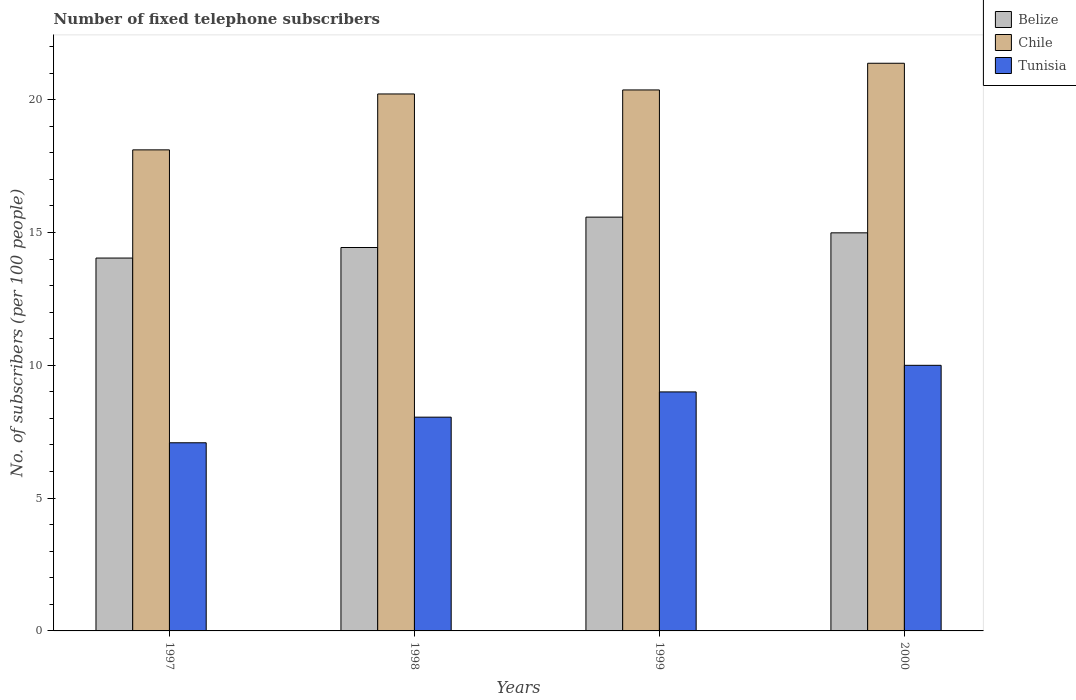How many groups of bars are there?
Your answer should be compact. 4. Are the number of bars per tick equal to the number of legend labels?
Give a very brief answer. Yes. Are the number of bars on each tick of the X-axis equal?
Your response must be concise. Yes. How many bars are there on the 4th tick from the left?
Offer a terse response. 3. How many bars are there on the 1st tick from the right?
Make the answer very short. 3. In how many cases, is the number of bars for a given year not equal to the number of legend labels?
Ensure brevity in your answer.  0. What is the number of fixed telephone subscribers in Belize in 1999?
Give a very brief answer. 15.58. Across all years, what is the maximum number of fixed telephone subscribers in Belize?
Offer a terse response. 15.58. Across all years, what is the minimum number of fixed telephone subscribers in Chile?
Offer a terse response. 18.11. In which year was the number of fixed telephone subscribers in Tunisia maximum?
Keep it short and to the point. 2000. In which year was the number of fixed telephone subscribers in Chile minimum?
Ensure brevity in your answer.  1997. What is the total number of fixed telephone subscribers in Chile in the graph?
Ensure brevity in your answer.  80.06. What is the difference between the number of fixed telephone subscribers in Tunisia in 1998 and that in 1999?
Make the answer very short. -0.95. What is the difference between the number of fixed telephone subscribers in Belize in 2000 and the number of fixed telephone subscribers in Chile in 1997?
Keep it short and to the point. -3.12. What is the average number of fixed telephone subscribers in Belize per year?
Provide a short and direct response. 14.76. In the year 2000, what is the difference between the number of fixed telephone subscribers in Tunisia and number of fixed telephone subscribers in Belize?
Your answer should be compact. -4.99. In how many years, is the number of fixed telephone subscribers in Belize greater than 3?
Your response must be concise. 4. What is the ratio of the number of fixed telephone subscribers in Belize in 1998 to that in 1999?
Make the answer very short. 0.93. Is the number of fixed telephone subscribers in Chile in 1998 less than that in 2000?
Your response must be concise. Yes. Is the difference between the number of fixed telephone subscribers in Tunisia in 1997 and 2000 greater than the difference between the number of fixed telephone subscribers in Belize in 1997 and 2000?
Provide a short and direct response. No. What is the difference between the highest and the second highest number of fixed telephone subscribers in Chile?
Provide a succinct answer. 1. What is the difference between the highest and the lowest number of fixed telephone subscribers in Belize?
Give a very brief answer. 1.54. In how many years, is the number of fixed telephone subscribers in Tunisia greater than the average number of fixed telephone subscribers in Tunisia taken over all years?
Make the answer very short. 2. What does the 3rd bar from the left in 1998 represents?
Offer a very short reply. Tunisia. What does the 1st bar from the right in 2000 represents?
Offer a very short reply. Tunisia. Is it the case that in every year, the sum of the number of fixed telephone subscribers in Tunisia and number of fixed telephone subscribers in Belize is greater than the number of fixed telephone subscribers in Chile?
Make the answer very short. Yes. How many bars are there?
Give a very brief answer. 12. Are the values on the major ticks of Y-axis written in scientific E-notation?
Offer a terse response. No. Does the graph contain any zero values?
Offer a terse response. No. Does the graph contain grids?
Provide a short and direct response. No. How many legend labels are there?
Ensure brevity in your answer.  3. How are the legend labels stacked?
Offer a terse response. Vertical. What is the title of the graph?
Provide a succinct answer. Number of fixed telephone subscribers. Does "North America" appear as one of the legend labels in the graph?
Make the answer very short. No. What is the label or title of the X-axis?
Offer a very short reply. Years. What is the label or title of the Y-axis?
Provide a short and direct response. No. of subscribers (per 100 people). What is the No. of subscribers (per 100 people) in Belize in 1997?
Your answer should be very brief. 14.04. What is the No. of subscribers (per 100 people) of Chile in 1997?
Offer a very short reply. 18.11. What is the No. of subscribers (per 100 people) in Tunisia in 1997?
Give a very brief answer. 7.08. What is the No. of subscribers (per 100 people) in Belize in 1998?
Ensure brevity in your answer.  14.43. What is the No. of subscribers (per 100 people) in Chile in 1998?
Provide a succinct answer. 20.21. What is the No. of subscribers (per 100 people) of Tunisia in 1998?
Give a very brief answer. 8.05. What is the No. of subscribers (per 100 people) in Belize in 1999?
Your answer should be compact. 15.58. What is the No. of subscribers (per 100 people) in Chile in 1999?
Provide a succinct answer. 20.36. What is the No. of subscribers (per 100 people) of Tunisia in 1999?
Your answer should be compact. 9. What is the No. of subscribers (per 100 people) in Belize in 2000?
Your answer should be compact. 14.99. What is the No. of subscribers (per 100 people) in Chile in 2000?
Make the answer very short. 21.37. What is the No. of subscribers (per 100 people) of Tunisia in 2000?
Offer a terse response. 10. Across all years, what is the maximum No. of subscribers (per 100 people) in Belize?
Offer a terse response. 15.58. Across all years, what is the maximum No. of subscribers (per 100 people) of Chile?
Offer a terse response. 21.37. Across all years, what is the maximum No. of subscribers (per 100 people) in Tunisia?
Give a very brief answer. 10. Across all years, what is the minimum No. of subscribers (per 100 people) of Belize?
Offer a terse response. 14.04. Across all years, what is the minimum No. of subscribers (per 100 people) of Chile?
Your answer should be compact. 18.11. Across all years, what is the minimum No. of subscribers (per 100 people) in Tunisia?
Your answer should be compact. 7.08. What is the total No. of subscribers (per 100 people) of Belize in the graph?
Provide a short and direct response. 59.03. What is the total No. of subscribers (per 100 people) of Chile in the graph?
Offer a terse response. 80.06. What is the total No. of subscribers (per 100 people) of Tunisia in the graph?
Your answer should be compact. 34.13. What is the difference between the No. of subscribers (per 100 people) of Belize in 1997 and that in 1998?
Ensure brevity in your answer.  -0.4. What is the difference between the No. of subscribers (per 100 people) in Chile in 1997 and that in 1998?
Offer a very short reply. -2.1. What is the difference between the No. of subscribers (per 100 people) in Tunisia in 1997 and that in 1998?
Offer a terse response. -0.96. What is the difference between the No. of subscribers (per 100 people) of Belize in 1997 and that in 1999?
Make the answer very short. -1.54. What is the difference between the No. of subscribers (per 100 people) of Chile in 1997 and that in 1999?
Make the answer very short. -2.26. What is the difference between the No. of subscribers (per 100 people) of Tunisia in 1997 and that in 1999?
Ensure brevity in your answer.  -1.91. What is the difference between the No. of subscribers (per 100 people) in Belize in 1997 and that in 2000?
Provide a succinct answer. -0.95. What is the difference between the No. of subscribers (per 100 people) of Chile in 1997 and that in 2000?
Keep it short and to the point. -3.26. What is the difference between the No. of subscribers (per 100 people) in Tunisia in 1997 and that in 2000?
Make the answer very short. -2.92. What is the difference between the No. of subscribers (per 100 people) in Belize in 1998 and that in 1999?
Offer a very short reply. -1.14. What is the difference between the No. of subscribers (per 100 people) of Chile in 1998 and that in 1999?
Provide a succinct answer. -0.15. What is the difference between the No. of subscribers (per 100 people) in Tunisia in 1998 and that in 1999?
Ensure brevity in your answer.  -0.95. What is the difference between the No. of subscribers (per 100 people) in Belize in 1998 and that in 2000?
Your answer should be compact. -0.55. What is the difference between the No. of subscribers (per 100 people) in Chile in 1998 and that in 2000?
Offer a very short reply. -1.16. What is the difference between the No. of subscribers (per 100 people) in Tunisia in 1998 and that in 2000?
Ensure brevity in your answer.  -1.95. What is the difference between the No. of subscribers (per 100 people) of Belize in 1999 and that in 2000?
Your response must be concise. 0.59. What is the difference between the No. of subscribers (per 100 people) of Chile in 1999 and that in 2000?
Make the answer very short. -1. What is the difference between the No. of subscribers (per 100 people) of Tunisia in 1999 and that in 2000?
Make the answer very short. -1. What is the difference between the No. of subscribers (per 100 people) of Belize in 1997 and the No. of subscribers (per 100 people) of Chile in 1998?
Your response must be concise. -6.18. What is the difference between the No. of subscribers (per 100 people) of Belize in 1997 and the No. of subscribers (per 100 people) of Tunisia in 1998?
Your answer should be very brief. 5.99. What is the difference between the No. of subscribers (per 100 people) in Chile in 1997 and the No. of subscribers (per 100 people) in Tunisia in 1998?
Provide a succinct answer. 10.06. What is the difference between the No. of subscribers (per 100 people) of Belize in 1997 and the No. of subscribers (per 100 people) of Chile in 1999?
Your response must be concise. -6.33. What is the difference between the No. of subscribers (per 100 people) in Belize in 1997 and the No. of subscribers (per 100 people) in Tunisia in 1999?
Your answer should be compact. 5.04. What is the difference between the No. of subscribers (per 100 people) of Chile in 1997 and the No. of subscribers (per 100 people) of Tunisia in 1999?
Your response must be concise. 9.11. What is the difference between the No. of subscribers (per 100 people) of Belize in 1997 and the No. of subscribers (per 100 people) of Chile in 2000?
Give a very brief answer. -7.33. What is the difference between the No. of subscribers (per 100 people) in Belize in 1997 and the No. of subscribers (per 100 people) in Tunisia in 2000?
Keep it short and to the point. 4.04. What is the difference between the No. of subscribers (per 100 people) of Chile in 1997 and the No. of subscribers (per 100 people) of Tunisia in 2000?
Offer a terse response. 8.11. What is the difference between the No. of subscribers (per 100 people) of Belize in 1998 and the No. of subscribers (per 100 people) of Chile in 1999?
Provide a short and direct response. -5.93. What is the difference between the No. of subscribers (per 100 people) of Belize in 1998 and the No. of subscribers (per 100 people) of Tunisia in 1999?
Ensure brevity in your answer.  5.44. What is the difference between the No. of subscribers (per 100 people) in Chile in 1998 and the No. of subscribers (per 100 people) in Tunisia in 1999?
Offer a very short reply. 11.22. What is the difference between the No. of subscribers (per 100 people) of Belize in 1998 and the No. of subscribers (per 100 people) of Chile in 2000?
Give a very brief answer. -6.94. What is the difference between the No. of subscribers (per 100 people) of Belize in 1998 and the No. of subscribers (per 100 people) of Tunisia in 2000?
Ensure brevity in your answer.  4.43. What is the difference between the No. of subscribers (per 100 people) in Chile in 1998 and the No. of subscribers (per 100 people) in Tunisia in 2000?
Offer a terse response. 10.22. What is the difference between the No. of subscribers (per 100 people) in Belize in 1999 and the No. of subscribers (per 100 people) in Chile in 2000?
Provide a short and direct response. -5.79. What is the difference between the No. of subscribers (per 100 people) in Belize in 1999 and the No. of subscribers (per 100 people) in Tunisia in 2000?
Keep it short and to the point. 5.58. What is the difference between the No. of subscribers (per 100 people) of Chile in 1999 and the No. of subscribers (per 100 people) of Tunisia in 2000?
Make the answer very short. 10.37. What is the average No. of subscribers (per 100 people) of Belize per year?
Offer a terse response. 14.76. What is the average No. of subscribers (per 100 people) in Chile per year?
Provide a succinct answer. 20.01. What is the average No. of subscribers (per 100 people) of Tunisia per year?
Offer a very short reply. 8.53. In the year 1997, what is the difference between the No. of subscribers (per 100 people) in Belize and No. of subscribers (per 100 people) in Chile?
Provide a short and direct response. -4.07. In the year 1997, what is the difference between the No. of subscribers (per 100 people) in Belize and No. of subscribers (per 100 people) in Tunisia?
Offer a very short reply. 6.95. In the year 1997, what is the difference between the No. of subscribers (per 100 people) of Chile and No. of subscribers (per 100 people) of Tunisia?
Offer a terse response. 11.03. In the year 1998, what is the difference between the No. of subscribers (per 100 people) of Belize and No. of subscribers (per 100 people) of Chile?
Your answer should be very brief. -5.78. In the year 1998, what is the difference between the No. of subscribers (per 100 people) of Belize and No. of subscribers (per 100 people) of Tunisia?
Your answer should be compact. 6.39. In the year 1998, what is the difference between the No. of subscribers (per 100 people) in Chile and No. of subscribers (per 100 people) in Tunisia?
Make the answer very short. 12.17. In the year 1999, what is the difference between the No. of subscribers (per 100 people) in Belize and No. of subscribers (per 100 people) in Chile?
Offer a very short reply. -4.79. In the year 1999, what is the difference between the No. of subscribers (per 100 people) of Belize and No. of subscribers (per 100 people) of Tunisia?
Provide a succinct answer. 6.58. In the year 1999, what is the difference between the No. of subscribers (per 100 people) of Chile and No. of subscribers (per 100 people) of Tunisia?
Give a very brief answer. 11.37. In the year 2000, what is the difference between the No. of subscribers (per 100 people) of Belize and No. of subscribers (per 100 people) of Chile?
Your answer should be very brief. -6.38. In the year 2000, what is the difference between the No. of subscribers (per 100 people) in Belize and No. of subscribers (per 100 people) in Tunisia?
Provide a succinct answer. 4.99. In the year 2000, what is the difference between the No. of subscribers (per 100 people) in Chile and No. of subscribers (per 100 people) in Tunisia?
Give a very brief answer. 11.37. What is the ratio of the No. of subscribers (per 100 people) of Belize in 1997 to that in 1998?
Your answer should be compact. 0.97. What is the ratio of the No. of subscribers (per 100 people) of Chile in 1997 to that in 1998?
Make the answer very short. 0.9. What is the ratio of the No. of subscribers (per 100 people) of Tunisia in 1997 to that in 1998?
Ensure brevity in your answer.  0.88. What is the ratio of the No. of subscribers (per 100 people) of Belize in 1997 to that in 1999?
Your response must be concise. 0.9. What is the ratio of the No. of subscribers (per 100 people) of Chile in 1997 to that in 1999?
Your answer should be compact. 0.89. What is the ratio of the No. of subscribers (per 100 people) of Tunisia in 1997 to that in 1999?
Your answer should be compact. 0.79. What is the ratio of the No. of subscribers (per 100 people) in Belize in 1997 to that in 2000?
Give a very brief answer. 0.94. What is the ratio of the No. of subscribers (per 100 people) of Chile in 1997 to that in 2000?
Your answer should be compact. 0.85. What is the ratio of the No. of subscribers (per 100 people) of Tunisia in 1997 to that in 2000?
Provide a succinct answer. 0.71. What is the ratio of the No. of subscribers (per 100 people) in Belize in 1998 to that in 1999?
Offer a terse response. 0.93. What is the ratio of the No. of subscribers (per 100 people) of Tunisia in 1998 to that in 1999?
Make the answer very short. 0.89. What is the ratio of the No. of subscribers (per 100 people) of Belize in 1998 to that in 2000?
Your answer should be very brief. 0.96. What is the ratio of the No. of subscribers (per 100 people) in Chile in 1998 to that in 2000?
Offer a very short reply. 0.95. What is the ratio of the No. of subscribers (per 100 people) in Tunisia in 1998 to that in 2000?
Keep it short and to the point. 0.8. What is the ratio of the No. of subscribers (per 100 people) of Belize in 1999 to that in 2000?
Ensure brevity in your answer.  1.04. What is the ratio of the No. of subscribers (per 100 people) in Chile in 1999 to that in 2000?
Your response must be concise. 0.95. What is the ratio of the No. of subscribers (per 100 people) of Tunisia in 1999 to that in 2000?
Provide a succinct answer. 0.9. What is the difference between the highest and the second highest No. of subscribers (per 100 people) in Belize?
Give a very brief answer. 0.59. What is the difference between the highest and the lowest No. of subscribers (per 100 people) in Belize?
Offer a very short reply. 1.54. What is the difference between the highest and the lowest No. of subscribers (per 100 people) of Chile?
Your response must be concise. 3.26. What is the difference between the highest and the lowest No. of subscribers (per 100 people) of Tunisia?
Make the answer very short. 2.92. 